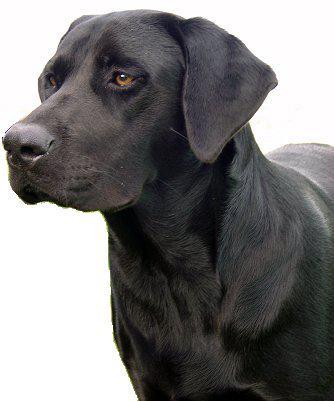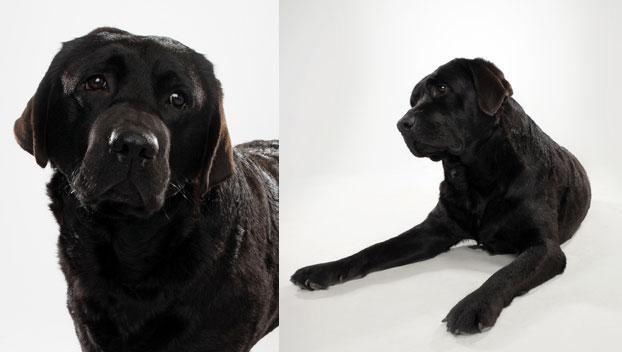The first image is the image on the left, the second image is the image on the right. For the images displayed, is the sentence "There are two dogs in the image on the right." factually correct? Answer yes or no. Yes. 